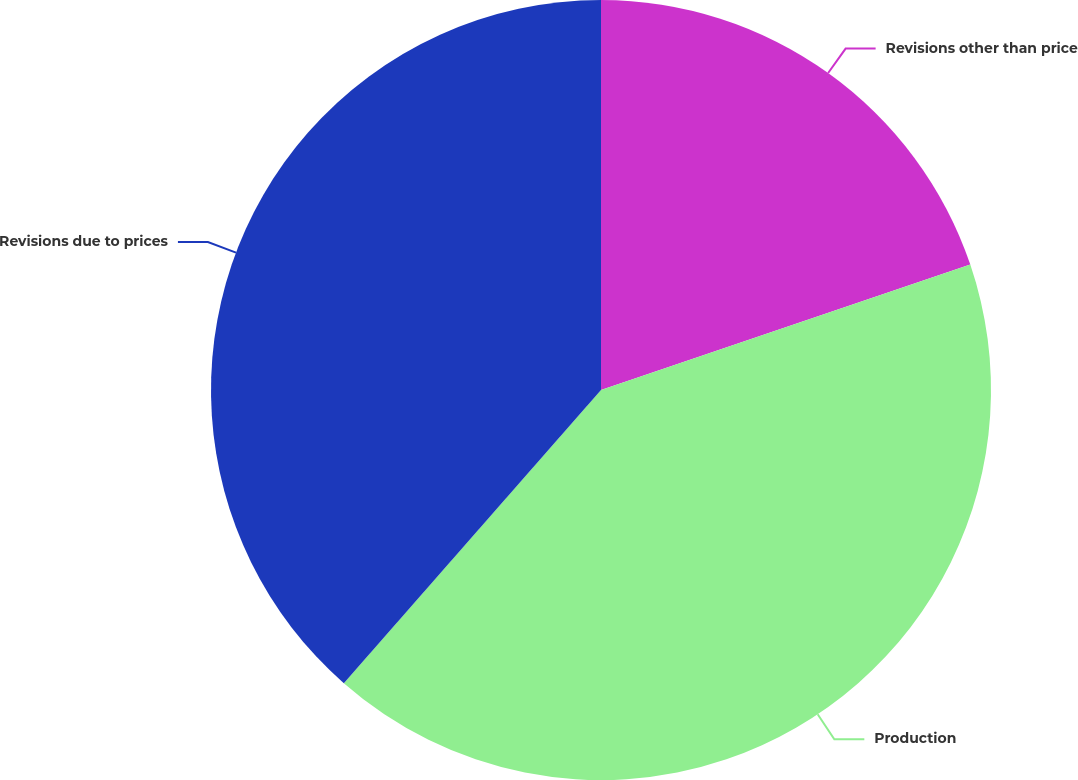Convert chart to OTSL. <chart><loc_0><loc_0><loc_500><loc_500><pie_chart><fcel>Revisions other than price<fcel>Production<fcel>Revisions due to prices<nl><fcel>19.79%<fcel>41.67%<fcel>38.54%<nl></chart> 